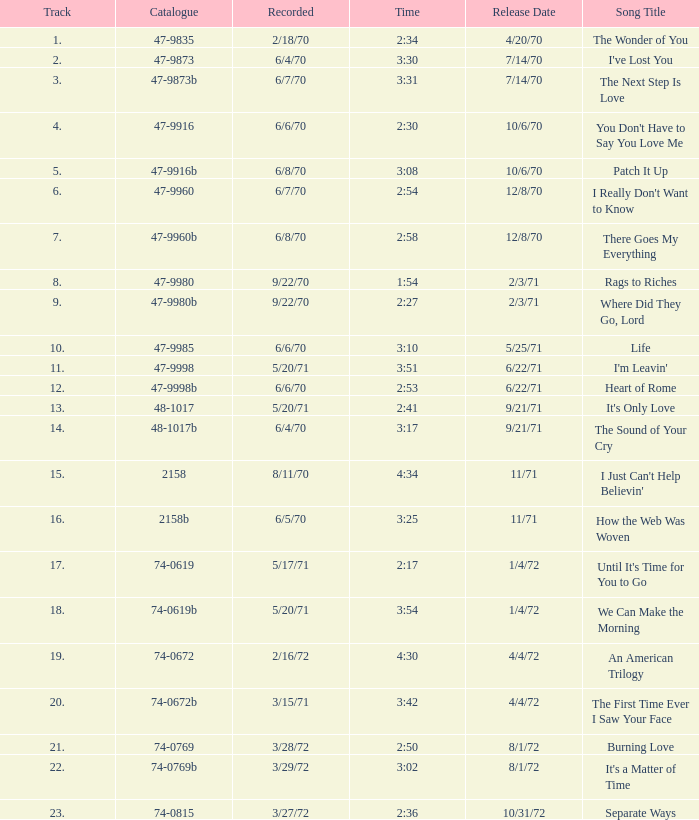What is the highest track for Burning Love? 21.0. 